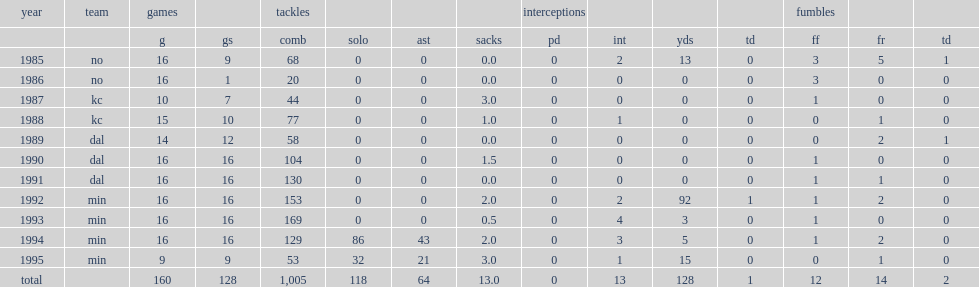How many games appearances did jack del rio finish his career with? 160.0. 